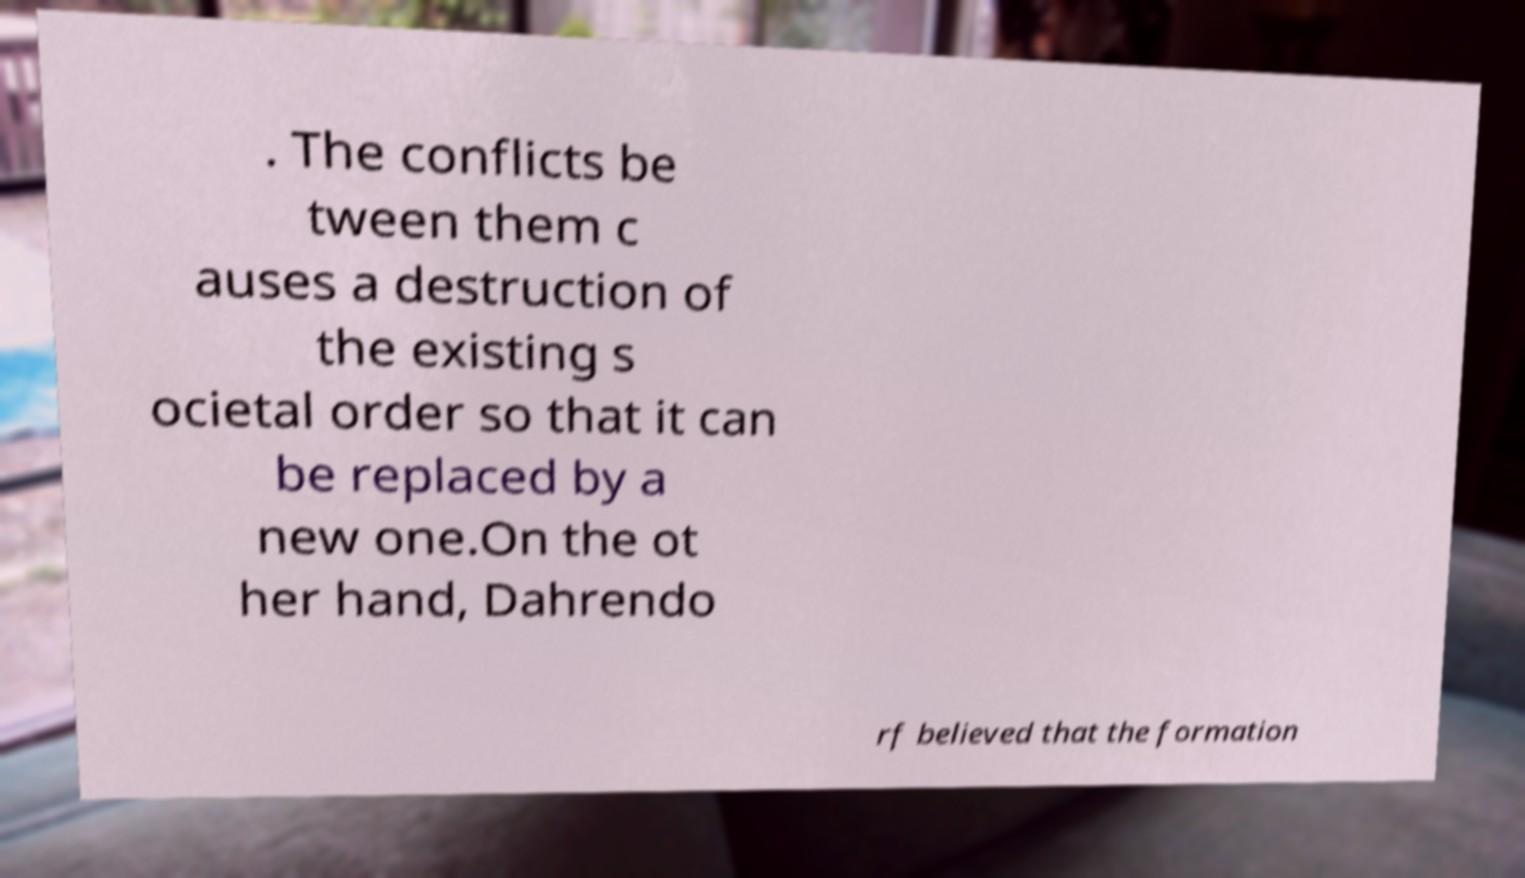There's text embedded in this image that I need extracted. Can you transcribe it verbatim? . The conflicts be tween them c auses a destruction of the existing s ocietal order so that it can be replaced by a new one.On the ot her hand, Dahrendo rf believed that the formation 